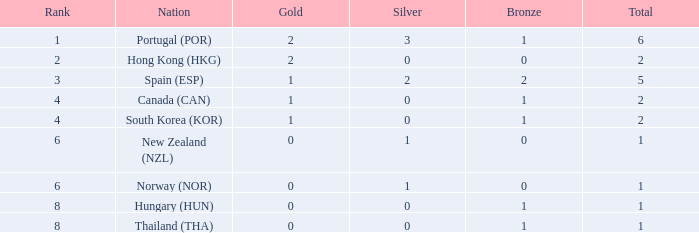Which Rank number has a Silver of 0, Gold of 2 and total smaller than 2? 0.0. Parse the table in full. {'header': ['Rank', 'Nation', 'Gold', 'Silver', 'Bronze', 'Total'], 'rows': [['1', 'Portugal (POR)', '2', '3', '1', '6'], ['2', 'Hong Kong (HKG)', '2', '0', '0', '2'], ['3', 'Spain (ESP)', '1', '2', '2', '5'], ['4', 'Canada (CAN)', '1', '0', '1', '2'], ['4', 'South Korea (KOR)', '1', '0', '1', '2'], ['6', 'New Zealand (NZL)', '0', '1', '0', '1'], ['6', 'Norway (NOR)', '0', '1', '0', '1'], ['8', 'Hungary (HUN)', '0', '0', '1', '1'], ['8', 'Thailand (THA)', '0', '0', '1', '1']]} 